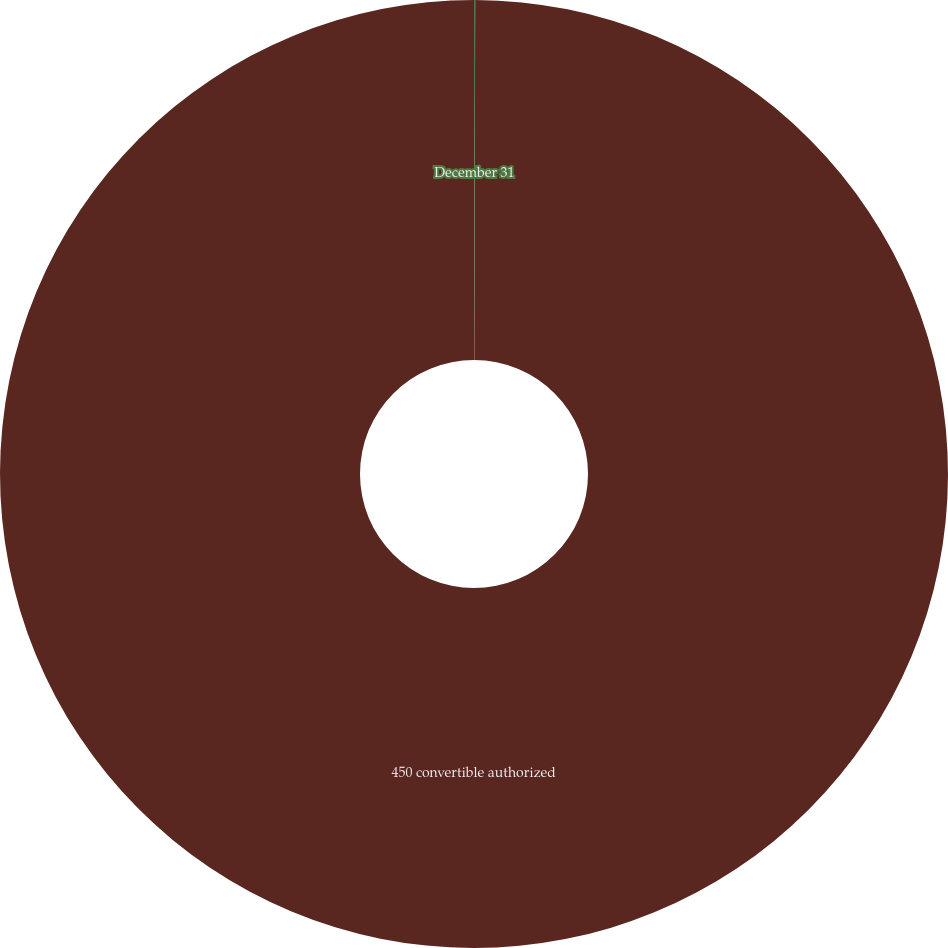<chart> <loc_0><loc_0><loc_500><loc_500><pie_chart><fcel>December 31<fcel>450 convertible authorized<nl><fcel>0.04%<fcel>99.96%<nl></chart> 